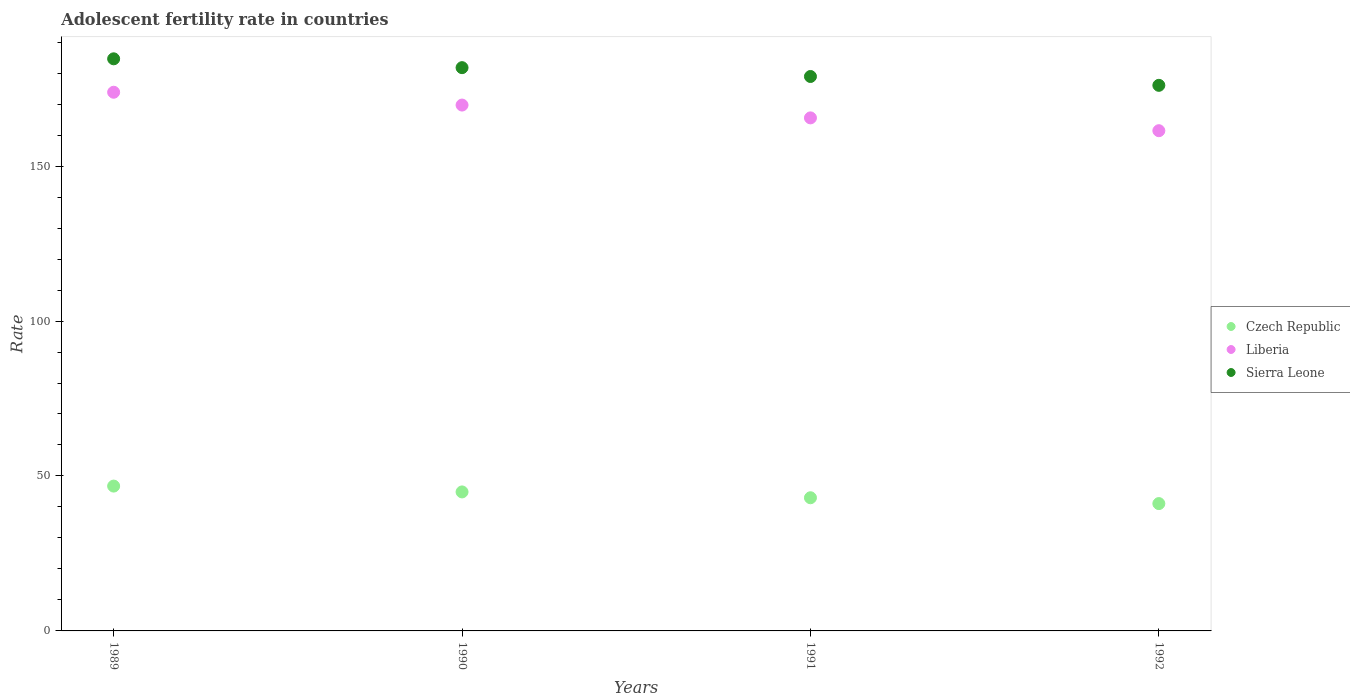What is the adolescent fertility rate in Sierra Leone in 1990?
Give a very brief answer. 181.76. Across all years, what is the maximum adolescent fertility rate in Sierra Leone?
Provide a succinct answer. 184.61. Across all years, what is the minimum adolescent fertility rate in Czech Republic?
Ensure brevity in your answer.  41.09. What is the total adolescent fertility rate in Czech Republic in the graph?
Your answer should be very brief. 175.65. What is the difference between the adolescent fertility rate in Sierra Leone in 1989 and that in 1991?
Give a very brief answer. 5.71. What is the difference between the adolescent fertility rate in Czech Republic in 1992 and the adolescent fertility rate in Liberia in 1989?
Give a very brief answer. -132.74. What is the average adolescent fertility rate in Czech Republic per year?
Keep it short and to the point. 43.91. In the year 1991, what is the difference between the adolescent fertility rate in Czech Republic and adolescent fertility rate in Sierra Leone?
Offer a very short reply. -135.94. What is the ratio of the adolescent fertility rate in Czech Republic in 1989 to that in 1992?
Offer a very short reply. 1.14. Is the difference between the adolescent fertility rate in Czech Republic in 1989 and 1991 greater than the difference between the adolescent fertility rate in Sierra Leone in 1989 and 1991?
Give a very brief answer. No. What is the difference between the highest and the second highest adolescent fertility rate in Liberia?
Ensure brevity in your answer.  4.14. What is the difference between the highest and the lowest adolescent fertility rate in Sierra Leone?
Keep it short and to the point. 8.56. Is the sum of the adolescent fertility rate in Czech Republic in 1989 and 1990 greater than the maximum adolescent fertility rate in Liberia across all years?
Offer a terse response. No. Are the values on the major ticks of Y-axis written in scientific E-notation?
Ensure brevity in your answer.  No. Does the graph contain any zero values?
Keep it short and to the point. No. Does the graph contain grids?
Provide a succinct answer. No. Where does the legend appear in the graph?
Provide a succinct answer. Center right. How many legend labels are there?
Keep it short and to the point. 3. What is the title of the graph?
Your answer should be compact. Adolescent fertility rate in countries. What is the label or title of the Y-axis?
Provide a short and direct response. Rate. What is the Rate in Czech Republic in 1989?
Make the answer very short. 46.74. What is the Rate in Liberia in 1989?
Keep it short and to the point. 173.82. What is the Rate in Sierra Leone in 1989?
Give a very brief answer. 184.61. What is the Rate of Czech Republic in 1990?
Offer a very short reply. 44.85. What is the Rate in Liberia in 1990?
Keep it short and to the point. 169.69. What is the Rate in Sierra Leone in 1990?
Ensure brevity in your answer.  181.76. What is the Rate in Czech Republic in 1991?
Make the answer very short. 42.97. What is the Rate of Liberia in 1991?
Ensure brevity in your answer.  165.55. What is the Rate of Sierra Leone in 1991?
Ensure brevity in your answer.  178.91. What is the Rate of Czech Republic in 1992?
Provide a short and direct response. 41.09. What is the Rate of Liberia in 1992?
Your answer should be compact. 161.42. What is the Rate of Sierra Leone in 1992?
Offer a very short reply. 176.06. Across all years, what is the maximum Rate of Czech Republic?
Give a very brief answer. 46.74. Across all years, what is the maximum Rate in Liberia?
Make the answer very short. 173.82. Across all years, what is the maximum Rate in Sierra Leone?
Offer a very short reply. 184.61. Across all years, what is the minimum Rate of Czech Republic?
Keep it short and to the point. 41.09. Across all years, what is the minimum Rate of Liberia?
Keep it short and to the point. 161.42. Across all years, what is the minimum Rate of Sierra Leone?
Offer a very short reply. 176.06. What is the total Rate in Czech Republic in the graph?
Keep it short and to the point. 175.65. What is the total Rate of Liberia in the graph?
Give a very brief answer. 670.48. What is the total Rate of Sierra Leone in the graph?
Provide a short and direct response. 721.34. What is the difference between the Rate in Czech Republic in 1989 and that in 1990?
Ensure brevity in your answer.  1.88. What is the difference between the Rate of Liberia in 1989 and that in 1990?
Ensure brevity in your answer.  4.14. What is the difference between the Rate of Sierra Leone in 1989 and that in 1990?
Ensure brevity in your answer.  2.85. What is the difference between the Rate in Czech Republic in 1989 and that in 1991?
Your answer should be very brief. 3.76. What is the difference between the Rate in Liberia in 1989 and that in 1991?
Your response must be concise. 8.27. What is the difference between the Rate in Sierra Leone in 1989 and that in 1991?
Make the answer very short. 5.71. What is the difference between the Rate of Czech Republic in 1989 and that in 1992?
Provide a short and direct response. 5.65. What is the difference between the Rate in Liberia in 1989 and that in 1992?
Your answer should be compact. 12.41. What is the difference between the Rate of Sierra Leone in 1989 and that in 1992?
Make the answer very short. 8.56. What is the difference between the Rate in Czech Republic in 1990 and that in 1991?
Offer a terse response. 1.88. What is the difference between the Rate in Liberia in 1990 and that in 1991?
Provide a succinct answer. 4.14. What is the difference between the Rate of Sierra Leone in 1990 and that in 1991?
Provide a succinct answer. 2.85. What is the difference between the Rate in Czech Republic in 1990 and that in 1992?
Provide a succinct answer. 3.76. What is the difference between the Rate of Liberia in 1990 and that in 1992?
Provide a short and direct response. 8.27. What is the difference between the Rate of Sierra Leone in 1990 and that in 1992?
Give a very brief answer. 5.71. What is the difference between the Rate of Czech Republic in 1991 and that in 1992?
Provide a short and direct response. 1.88. What is the difference between the Rate of Liberia in 1991 and that in 1992?
Make the answer very short. 4.14. What is the difference between the Rate of Sierra Leone in 1991 and that in 1992?
Provide a succinct answer. 2.85. What is the difference between the Rate of Czech Republic in 1989 and the Rate of Liberia in 1990?
Ensure brevity in your answer.  -122.95. What is the difference between the Rate of Czech Republic in 1989 and the Rate of Sierra Leone in 1990?
Give a very brief answer. -135.02. What is the difference between the Rate of Liberia in 1989 and the Rate of Sierra Leone in 1990?
Your answer should be very brief. -7.94. What is the difference between the Rate in Czech Republic in 1989 and the Rate in Liberia in 1991?
Make the answer very short. -118.82. What is the difference between the Rate in Czech Republic in 1989 and the Rate in Sierra Leone in 1991?
Provide a succinct answer. -132.17. What is the difference between the Rate in Liberia in 1989 and the Rate in Sierra Leone in 1991?
Keep it short and to the point. -5.08. What is the difference between the Rate in Czech Republic in 1989 and the Rate in Liberia in 1992?
Your response must be concise. -114.68. What is the difference between the Rate of Czech Republic in 1989 and the Rate of Sierra Leone in 1992?
Make the answer very short. -129.32. What is the difference between the Rate of Liberia in 1989 and the Rate of Sierra Leone in 1992?
Keep it short and to the point. -2.23. What is the difference between the Rate of Czech Republic in 1990 and the Rate of Liberia in 1991?
Make the answer very short. -120.7. What is the difference between the Rate of Czech Republic in 1990 and the Rate of Sierra Leone in 1991?
Make the answer very short. -134.05. What is the difference between the Rate of Liberia in 1990 and the Rate of Sierra Leone in 1991?
Provide a short and direct response. -9.22. What is the difference between the Rate of Czech Republic in 1990 and the Rate of Liberia in 1992?
Provide a succinct answer. -116.56. What is the difference between the Rate of Czech Republic in 1990 and the Rate of Sierra Leone in 1992?
Your answer should be very brief. -131.2. What is the difference between the Rate in Liberia in 1990 and the Rate in Sierra Leone in 1992?
Ensure brevity in your answer.  -6.37. What is the difference between the Rate of Czech Republic in 1991 and the Rate of Liberia in 1992?
Ensure brevity in your answer.  -118.45. What is the difference between the Rate in Czech Republic in 1991 and the Rate in Sierra Leone in 1992?
Give a very brief answer. -133.08. What is the difference between the Rate of Liberia in 1991 and the Rate of Sierra Leone in 1992?
Your answer should be very brief. -10.5. What is the average Rate in Czech Republic per year?
Provide a short and direct response. 43.91. What is the average Rate of Liberia per year?
Keep it short and to the point. 167.62. What is the average Rate of Sierra Leone per year?
Your response must be concise. 180.33. In the year 1989, what is the difference between the Rate in Czech Republic and Rate in Liberia?
Give a very brief answer. -127.09. In the year 1989, what is the difference between the Rate in Czech Republic and Rate in Sierra Leone?
Your answer should be very brief. -137.88. In the year 1989, what is the difference between the Rate of Liberia and Rate of Sierra Leone?
Provide a short and direct response. -10.79. In the year 1990, what is the difference between the Rate of Czech Republic and Rate of Liberia?
Provide a short and direct response. -124.84. In the year 1990, what is the difference between the Rate in Czech Republic and Rate in Sierra Leone?
Give a very brief answer. -136.91. In the year 1990, what is the difference between the Rate of Liberia and Rate of Sierra Leone?
Your answer should be very brief. -12.07. In the year 1991, what is the difference between the Rate in Czech Republic and Rate in Liberia?
Keep it short and to the point. -122.58. In the year 1991, what is the difference between the Rate in Czech Republic and Rate in Sierra Leone?
Your response must be concise. -135.94. In the year 1991, what is the difference between the Rate in Liberia and Rate in Sierra Leone?
Your answer should be compact. -13.35. In the year 1992, what is the difference between the Rate of Czech Republic and Rate of Liberia?
Offer a terse response. -120.33. In the year 1992, what is the difference between the Rate in Czech Republic and Rate in Sierra Leone?
Your answer should be compact. -134.97. In the year 1992, what is the difference between the Rate of Liberia and Rate of Sierra Leone?
Your answer should be very brief. -14.64. What is the ratio of the Rate of Czech Republic in 1989 to that in 1990?
Provide a succinct answer. 1.04. What is the ratio of the Rate in Liberia in 1989 to that in 1990?
Give a very brief answer. 1.02. What is the ratio of the Rate in Sierra Leone in 1989 to that in 1990?
Make the answer very short. 1.02. What is the ratio of the Rate of Czech Republic in 1989 to that in 1991?
Keep it short and to the point. 1.09. What is the ratio of the Rate in Liberia in 1989 to that in 1991?
Your answer should be compact. 1.05. What is the ratio of the Rate in Sierra Leone in 1989 to that in 1991?
Offer a terse response. 1.03. What is the ratio of the Rate in Czech Republic in 1989 to that in 1992?
Your answer should be compact. 1.14. What is the ratio of the Rate of Liberia in 1989 to that in 1992?
Your response must be concise. 1.08. What is the ratio of the Rate in Sierra Leone in 1989 to that in 1992?
Keep it short and to the point. 1.05. What is the ratio of the Rate in Czech Republic in 1990 to that in 1991?
Provide a short and direct response. 1.04. What is the ratio of the Rate in Sierra Leone in 1990 to that in 1991?
Your answer should be compact. 1.02. What is the ratio of the Rate of Czech Republic in 1990 to that in 1992?
Your response must be concise. 1.09. What is the ratio of the Rate in Liberia in 1990 to that in 1992?
Offer a terse response. 1.05. What is the ratio of the Rate of Sierra Leone in 1990 to that in 1992?
Your answer should be very brief. 1.03. What is the ratio of the Rate of Czech Republic in 1991 to that in 1992?
Your answer should be very brief. 1.05. What is the ratio of the Rate of Liberia in 1991 to that in 1992?
Your answer should be very brief. 1.03. What is the ratio of the Rate in Sierra Leone in 1991 to that in 1992?
Give a very brief answer. 1.02. What is the difference between the highest and the second highest Rate of Czech Republic?
Make the answer very short. 1.88. What is the difference between the highest and the second highest Rate of Liberia?
Your response must be concise. 4.14. What is the difference between the highest and the second highest Rate of Sierra Leone?
Make the answer very short. 2.85. What is the difference between the highest and the lowest Rate of Czech Republic?
Keep it short and to the point. 5.65. What is the difference between the highest and the lowest Rate in Liberia?
Ensure brevity in your answer.  12.41. What is the difference between the highest and the lowest Rate of Sierra Leone?
Provide a short and direct response. 8.56. 